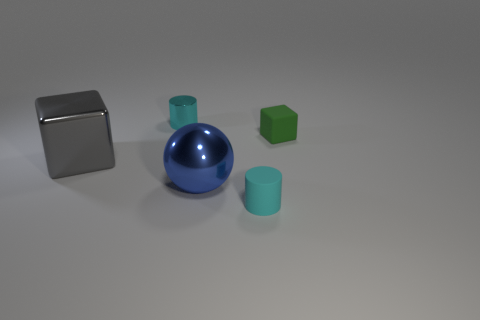Add 1 cylinders. How many objects exist? 6 Subtract all cylinders. How many objects are left? 3 Add 3 big gray cubes. How many big gray cubes are left? 4 Add 4 tiny cyan metallic objects. How many tiny cyan metallic objects exist? 5 Subtract 0 purple cubes. How many objects are left? 5 Subtract all blue metallic objects. Subtract all blue things. How many objects are left? 3 